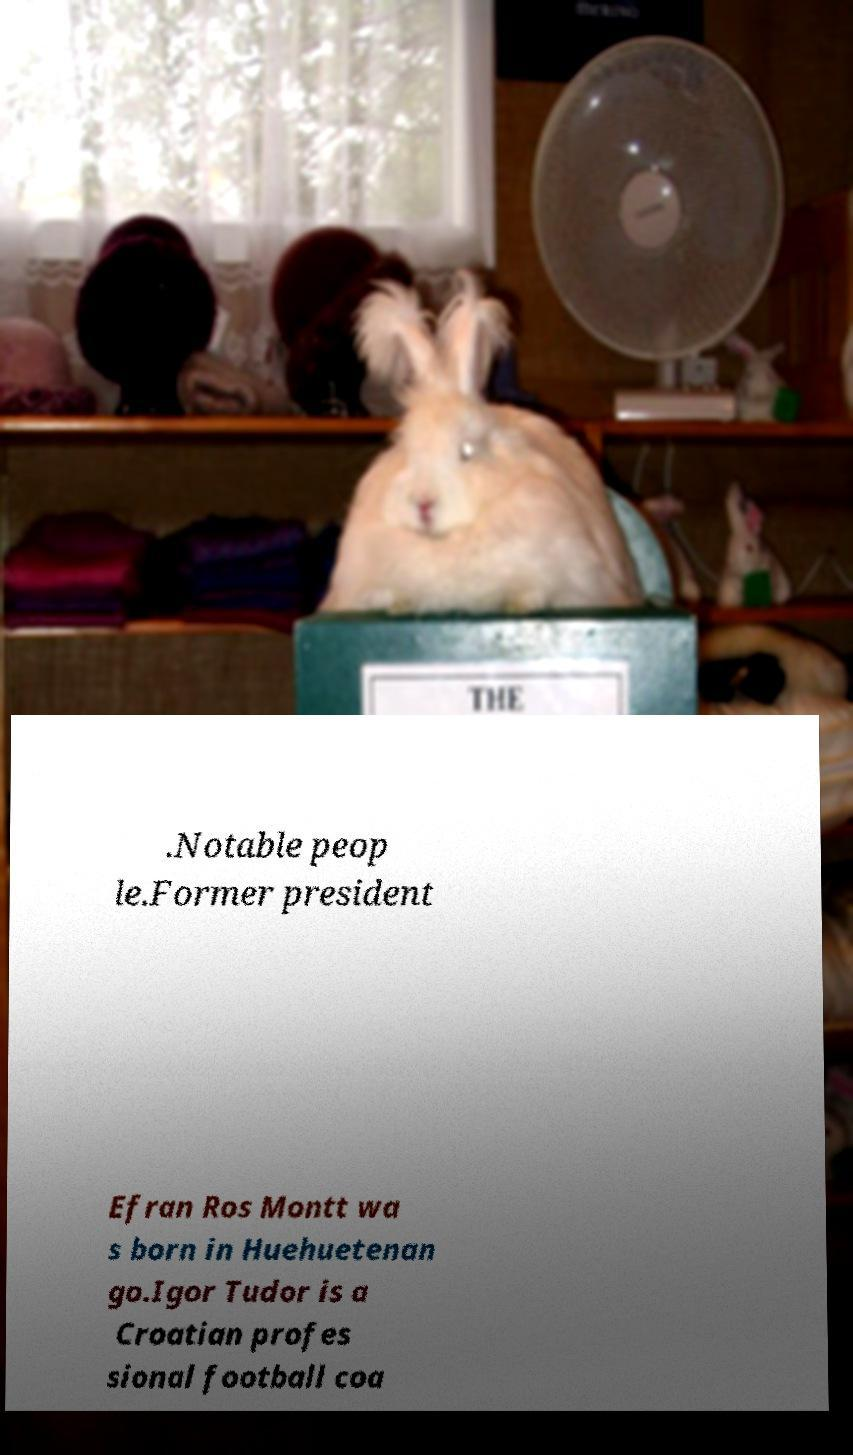Please identify and transcribe the text found in this image. .Notable peop le.Former president Efran Ros Montt wa s born in Huehuetenan go.Igor Tudor is a Croatian profes sional football coa 